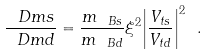Convert formula to latex. <formula><loc_0><loc_0><loc_500><loc_500>\frac { \ D m s } { \ D m d } = \frac { m _ { \ B s } } { m _ { \ B d } } \xi ^ { 2 } { \left | \frac { V _ { t s } } { V _ { t d } } \right | } ^ { 2 } \ .</formula> 